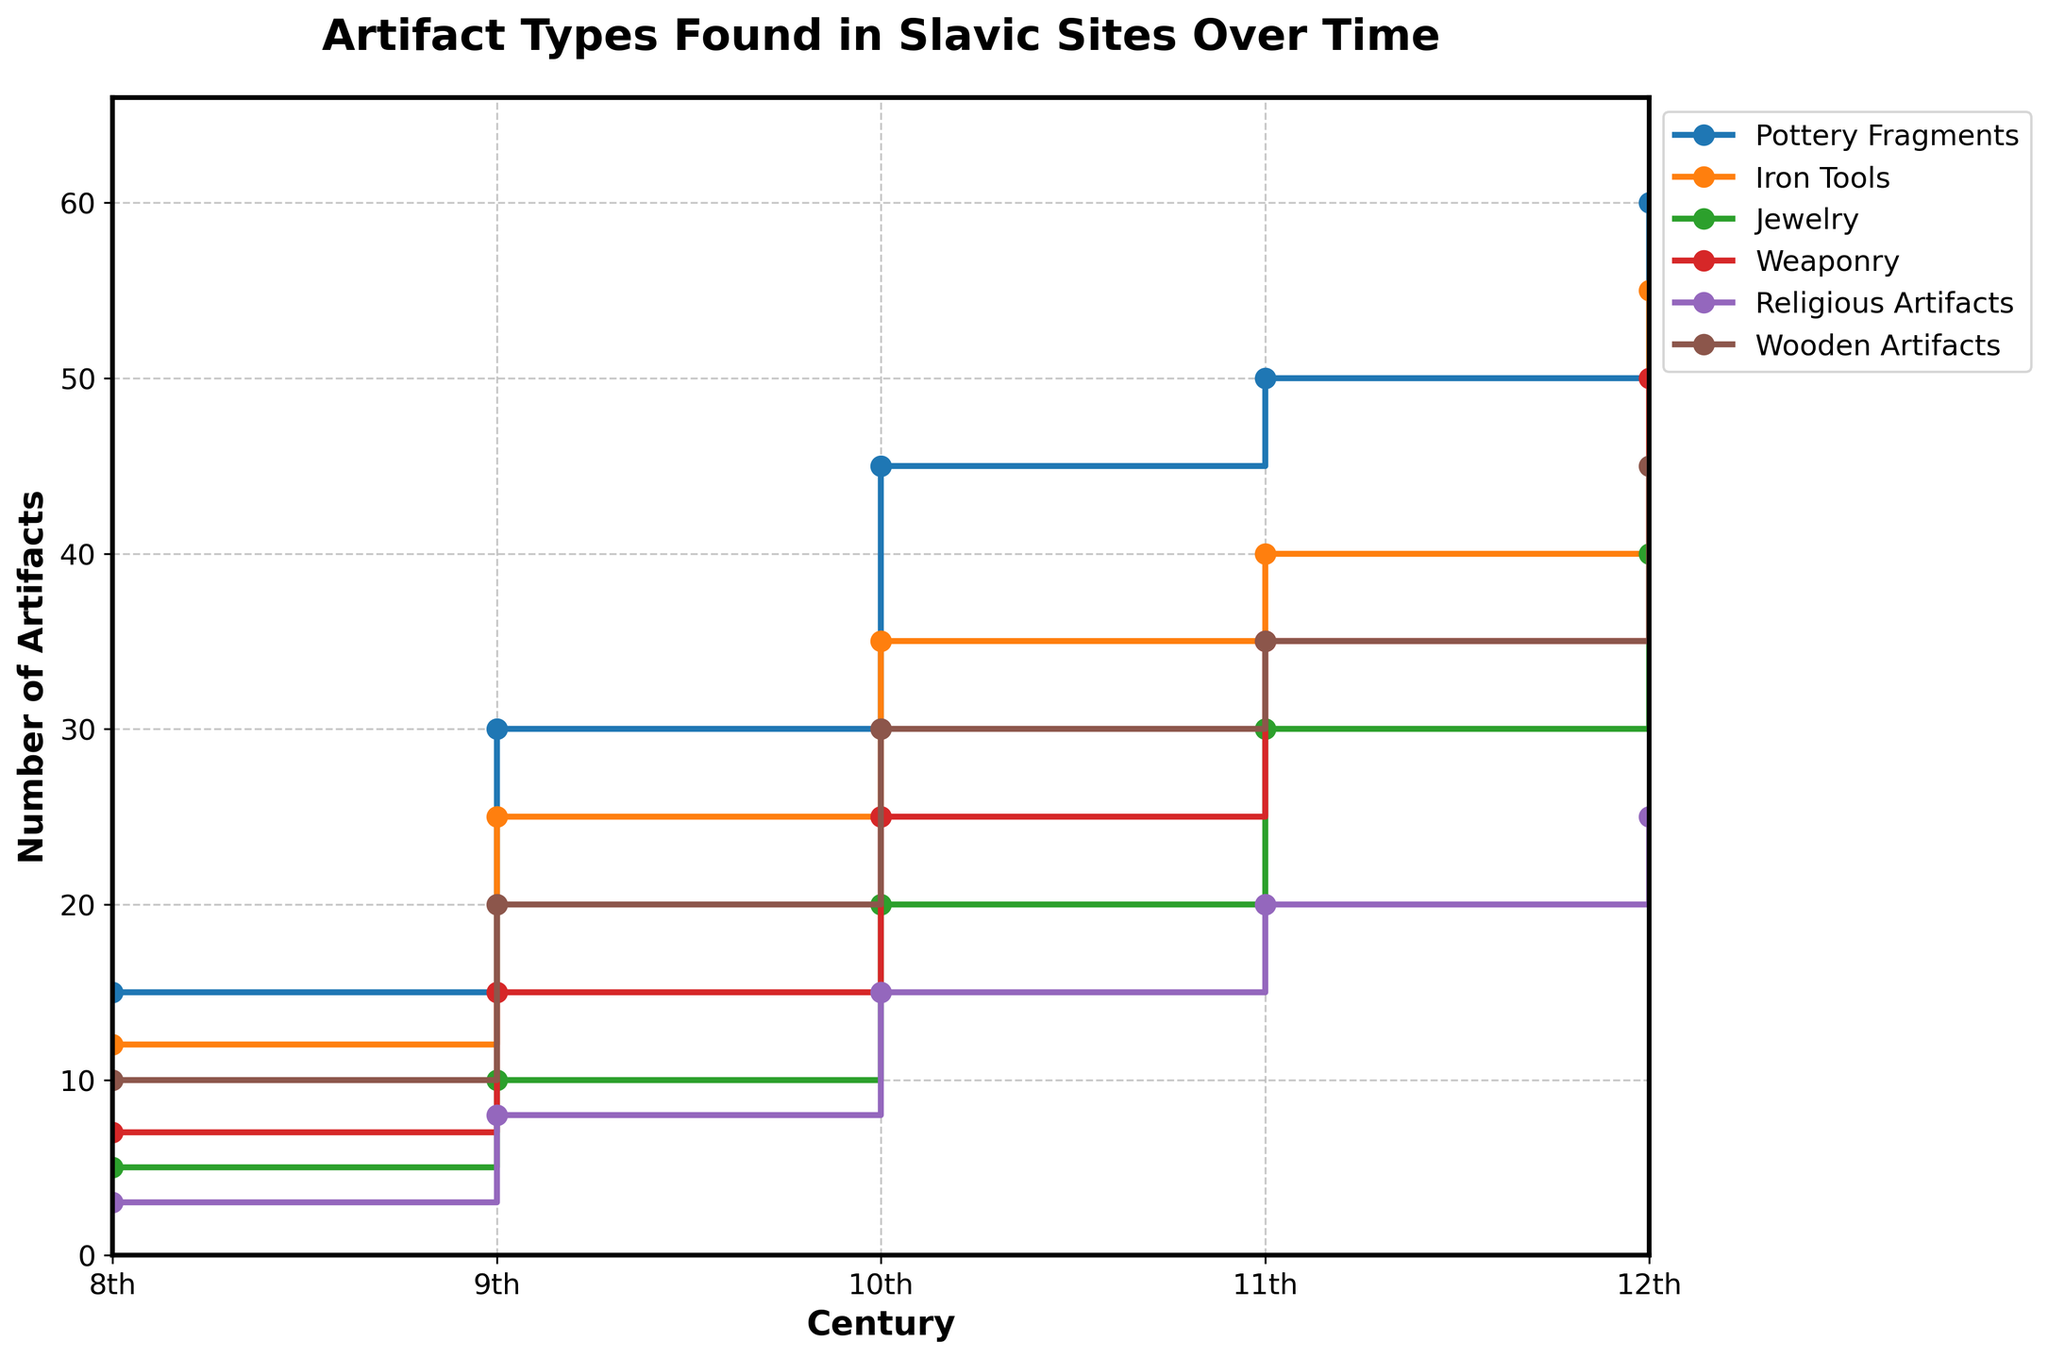What is the title of the figure? The title of the figure is displayed at the top and it describes the main subject of the visualization.
Answer: Artifact Types Found in Slavic Sites Over Time How many centuries are represented in the figure? The x-axis lists the centuries, which indicates the span of the timeline covered in the figure. Count the labels from '8th' to '12th'.
Answer: 5 Which type of artifact shows the greatest increase in quantity from the 8th to the 12th century? By examining the end points of each stair line, identify the artifact with the largest difference between its 8th and 12th-century values.
Answer: Pottery Fragments What is the total number of Iron Tools found over all centuries? Add the quantities of Iron Tools found across each century: 12 (8th) + 25 (9th) + 35 (10th) + 40 (11th) + 55 (12th).
Answer: 167 Which century saw the highest number of Jewelry artifacts? Look at the data points for Jewelry across each century and identify the century with the maximum value.
Answer: 12th Century In which century were Religious Artifacts most commonly found? Locate the highest value on the line representing Religious Artifacts and determine the corresponding century on the x-axis.
Answer: 12th Century Compare the number of Weaponry artifacts found in the 9th century with those found in the 11th century. Which has more and by how much? Subtract the number of Weaponry artifacts in the 9th century from the number in the 11th century: 35 (11th) - 15 (9th).
Answer: 11th Century, 20 more What is the average number of Wooden Artifacts found per century? Calculate the sum of Wooden Artifacts across all centuries and divide by the number of centuries: (10 + 20 + 30 + 35 + 45) / 5.
Answer: 28 Among all artifact types, which one showed a decreasing trend in any century-to-century transition? Examine the stair lines for each artifact type. Note any segments where the line goes downward rather than upward or flat.
Answer: None 